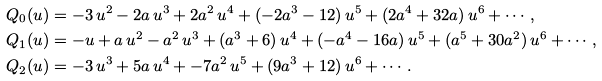<formula> <loc_0><loc_0><loc_500><loc_500>Q _ { 0 } ( u ) & = - 3 \, u ^ { 2 } - 2 a \, u ^ { 3 } + 2 a ^ { 2 } \, u ^ { 4 } + ( - 2 a ^ { 3 } - 1 2 ) \, u ^ { 5 } + ( 2 a ^ { 4 } + 3 2 a ) \, u ^ { 6 } + \cdots , \\ Q _ { 1 } ( u ) & = - u + a \, u ^ { 2 } - a ^ { 2 } \, u ^ { 3 } + ( a ^ { 3 } + 6 ) \, u ^ { 4 } + ( - a ^ { 4 } - 1 6 a ) \, u ^ { 5 } + ( a ^ { 5 } + 3 0 a ^ { 2 } ) \, u ^ { 6 } + \cdots , \\ Q _ { 2 } ( u ) & = - 3 \, u ^ { 3 } + 5 a \, u ^ { 4 } + - 7 a ^ { 2 } \, u ^ { 5 } + ( 9 a ^ { 3 } + 1 2 ) \, u ^ { 6 } + \cdots .</formula> 